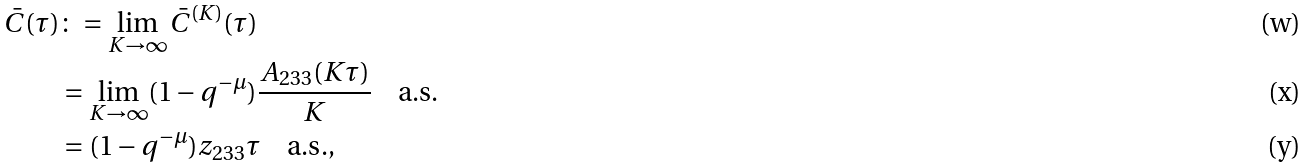Convert formula to latex. <formula><loc_0><loc_0><loc_500><loc_500>\bar { C } ( \tau ) & \colon = \lim _ { K \rightarrow \infty } \bar { C } ^ { ( K ) } ( \tau ) \\ & = \lim _ { K \rightarrow \infty } ( 1 - q ^ { - \mu } ) \frac { A _ { 2 3 3 } ( K \tau ) } { K } \quad \text {a.s.} \\ & = ( 1 - q ^ { - \mu } ) z _ { 2 3 3 } \tau \quad \text {a.s.} ,</formula> 